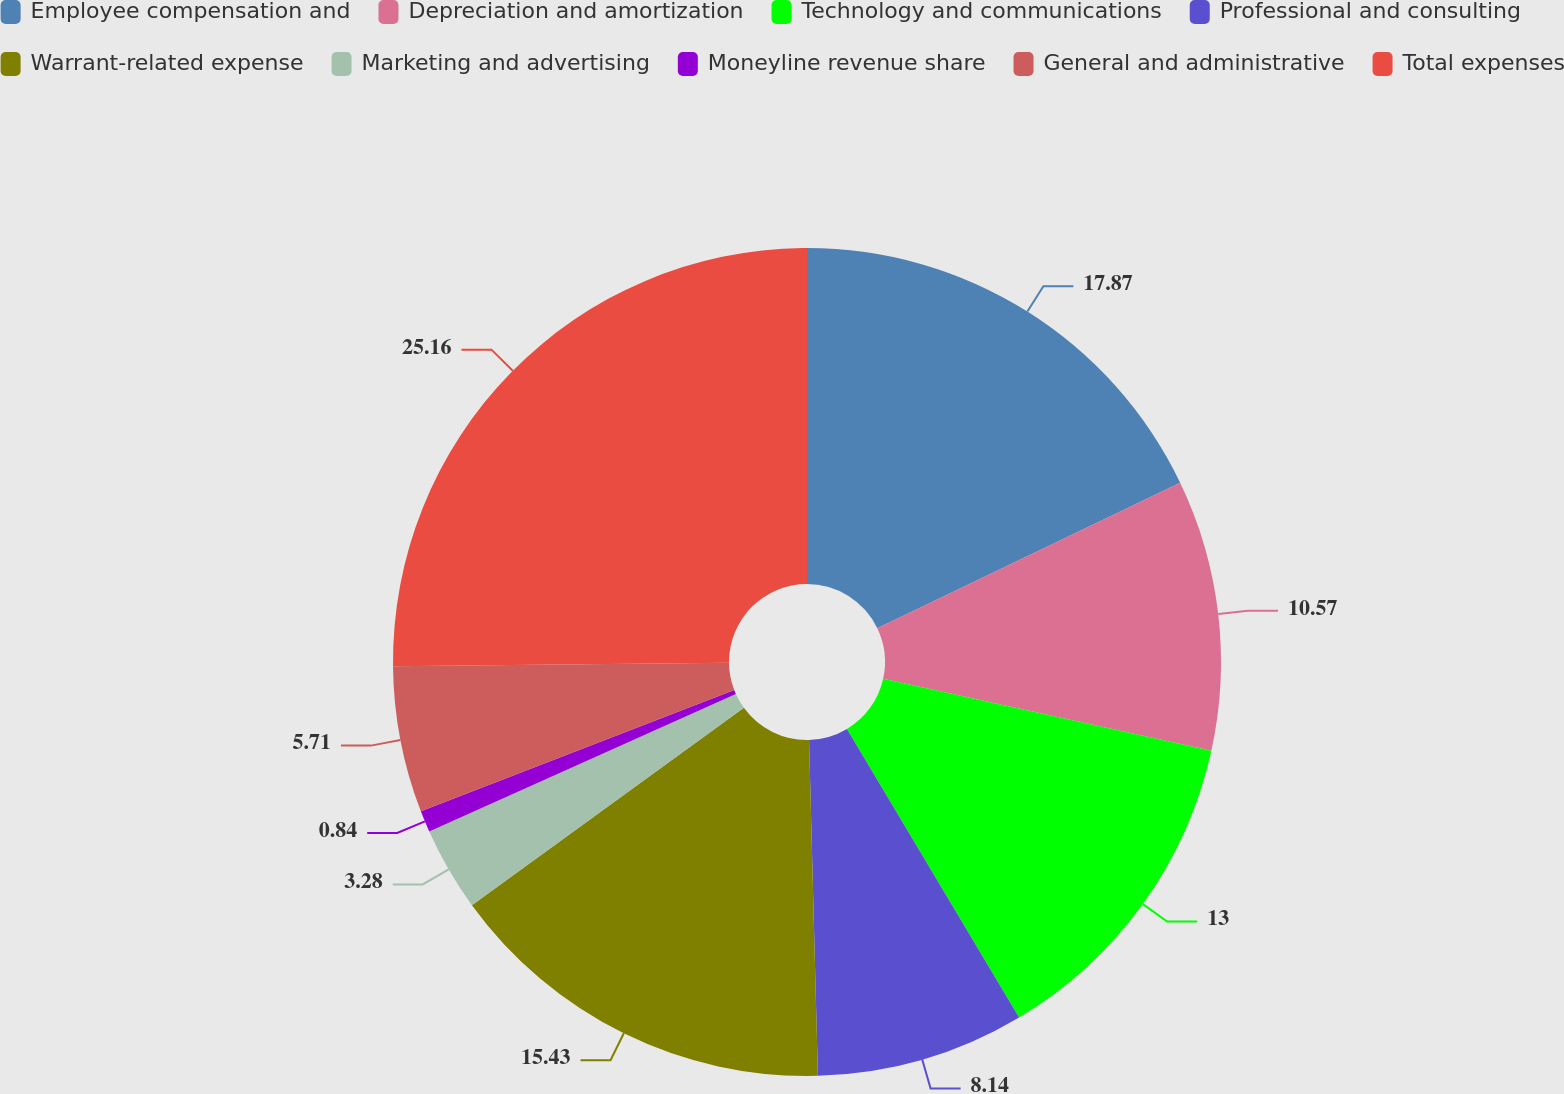Convert chart. <chart><loc_0><loc_0><loc_500><loc_500><pie_chart><fcel>Employee compensation and<fcel>Depreciation and amortization<fcel>Technology and communications<fcel>Professional and consulting<fcel>Warrant-related expense<fcel>Marketing and advertising<fcel>Moneyline revenue share<fcel>General and administrative<fcel>Total expenses<nl><fcel>17.87%<fcel>10.57%<fcel>13.0%<fcel>8.14%<fcel>15.43%<fcel>3.28%<fcel>0.84%<fcel>5.71%<fcel>25.16%<nl></chart> 